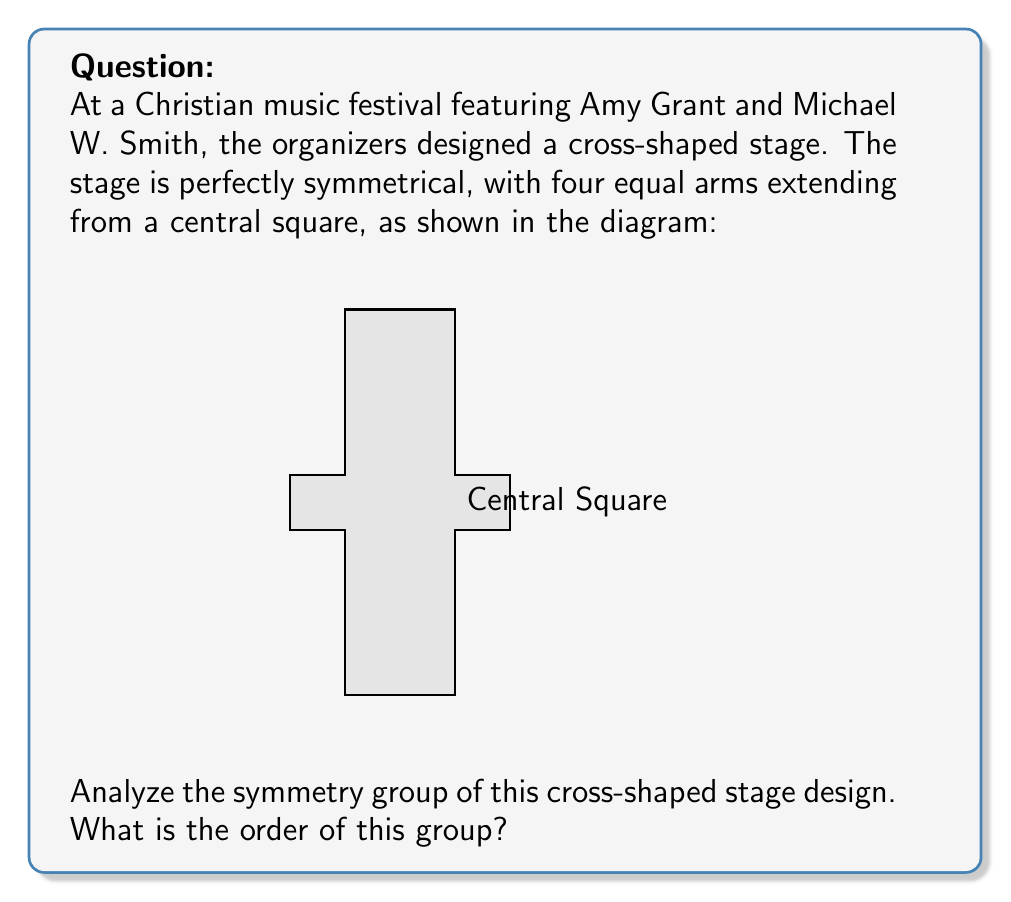What is the answer to this math problem? Let's approach this step-by-step:

1) First, we need to identify all the symmetries of this cross-shaped stage:

   a) Rotational symmetries:
      - Identity (0° rotation)
      - 90° clockwise rotation
      - 180° rotation
      - 270° clockwise rotation (or 90° counterclockwise)

   b) Reflection symmetries:
      - Reflection across the vertical axis
      - Reflection across the horizontal axis
      - Reflection across the diagonal from top-left to bottom-right
      - Reflection across the diagonal from top-right to bottom-left

2) Count the total number of symmetries:
   4 rotations + 4 reflections = 8 symmetries

3) These symmetries form a group under composition. This group is isomorphic to the dihedral group $D_4$, which is the symmetry group of a square.

4) The order of a group is the number of elements in the group.

Therefore, the order of the symmetry group of this cross-shaped stage is 8.

This symmetry group, $D_4$, has the following properties:
- It's non-abelian (not all elements commute)
- It has 5 conjugacy classes
- It has 5 irreducible representations
- Its center is of order 2

These properties reflect the rich symmetry of the cross shape, which is fitting for a Christian music festival stage featuring iconic artists like Amy Grant and Michael W. Smith.
Answer: 8 